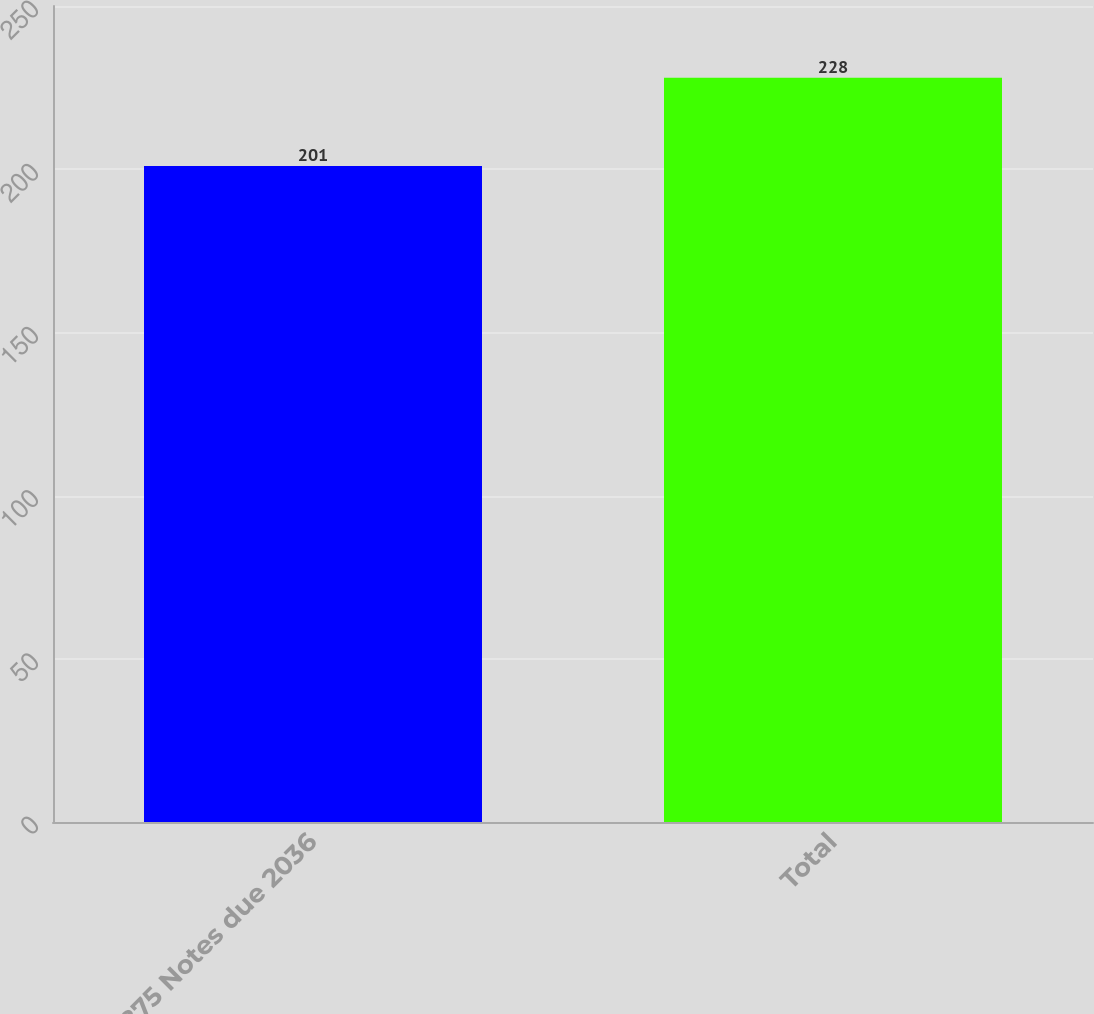Convert chart. <chart><loc_0><loc_0><loc_500><loc_500><bar_chart><fcel>5875 Notes due 2036<fcel>Total<nl><fcel>201<fcel>228<nl></chart> 